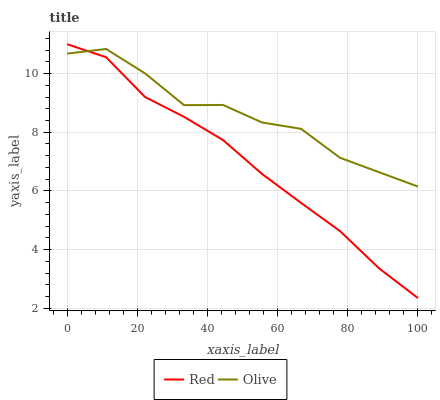Does Red have the maximum area under the curve?
Answer yes or no. No. Is Red the roughest?
Answer yes or no. No. 